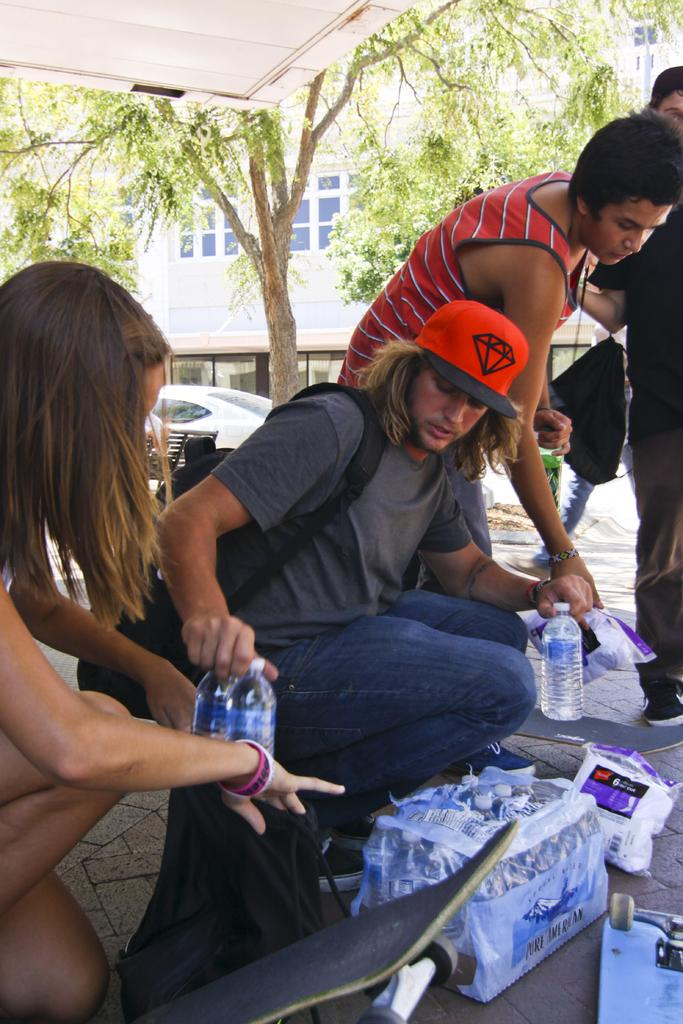What are the persons holding in the image? The persons are holding a bottle and a cover in the image. What else can be seen in the image besides the persons and their items? There is a bag, an object, a building, a vehicle, and a tree in the background. What is the theory behind the route taken by the sack in the image? There is no sack present in the image, and therefore no route or theory related to it can be discussed. 